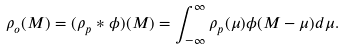Convert formula to latex. <formula><loc_0><loc_0><loc_500><loc_500>\rho _ { o } ( M ) = ( \rho _ { p } \ast \phi ) ( M ) = \int _ { - \infty } ^ { \infty } \rho _ { p } ( \mu ) \phi ( M - \mu ) d \mu .</formula> 